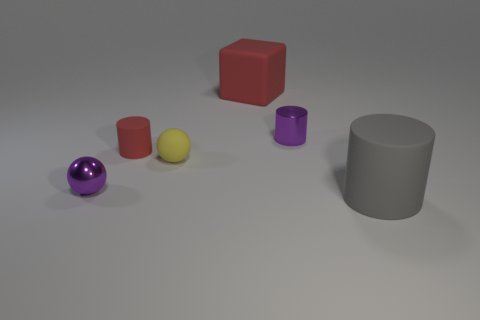Subtract all spheres. How many objects are left? 4 Add 3 big rubber balls. How many objects exist? 9 Subtract all blue cylinders. Subtract all gray objects. How many objects are left? 5 Add 6 tiny red rubber cylinders. How many tiny red rubber cylinders are left? 7 Add 3 tiny rubber things. How many tiny rubber things exist? 5 Subtract 1 purple balls. How many objects are left? 5 